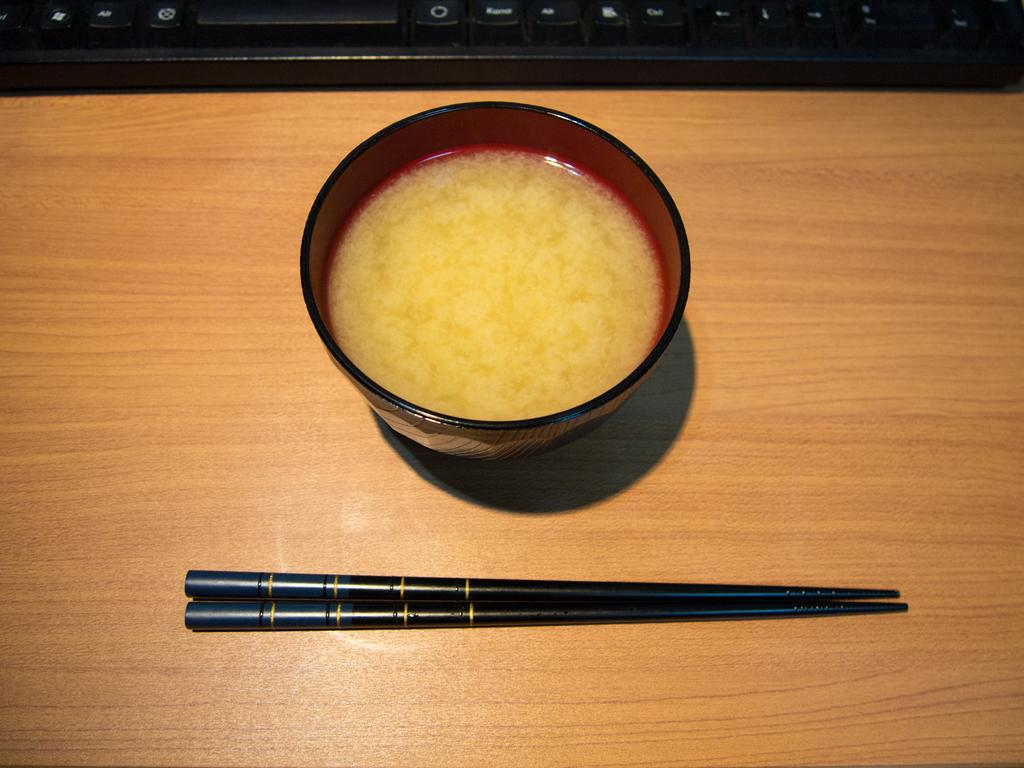What piece of furniture is present in the image? There is a table in the image. What object can be seen on the table? There is a cup on the table. What other item is on the table? There is a keyboard on the table. Are there any utensils on the table? Yes, there is a fork on the table. What type of gun is visible on the table in the image? There is no gun present in the image; the objects on the table include a cup, a keyboard, and a fork. 